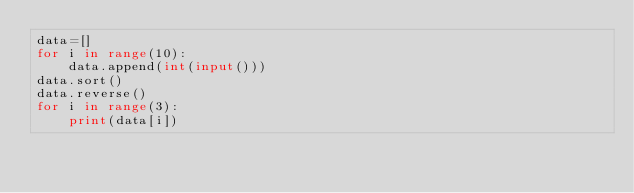<code> <loc_0><loc_0><loc_500><loc_500><_Python_>data=[]
for i in range(10):
    data.append(int(input()))
data.sort()
data.reverse()
for i in range(3):
    print(data[i])</code> 